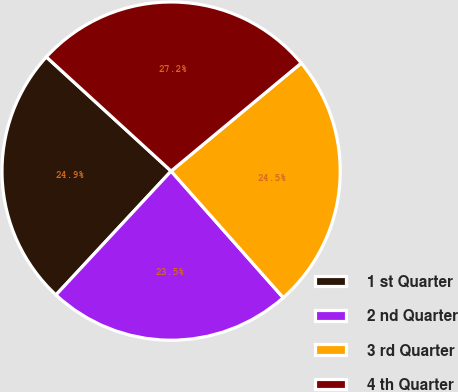<chart> <loc_0><loc_0><loc_500><loc_500><pie_chart><fcel>1 st Quarter<fcel>2 nd Quarter<fcel>3 rd Quarter<fcel>4 th Quarter<nl><fcel>24.87%<fcel>23.46%<fcel>24.49%<fcel>27.18%<nl></chart> 